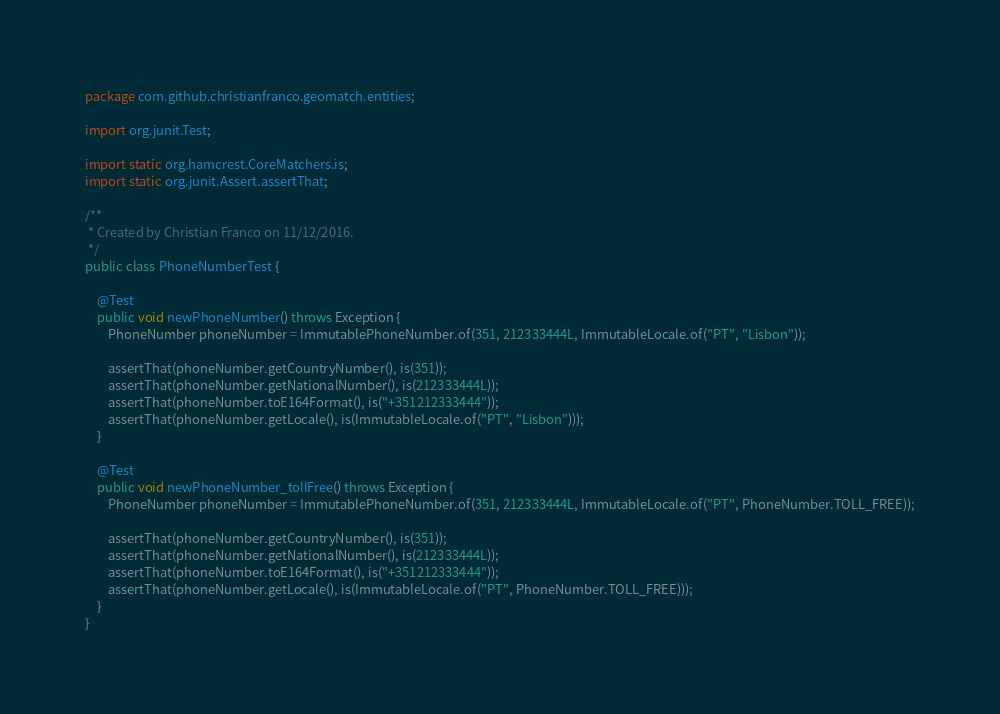<code> <loc_0><loc_0><loc_500><loc_500><_Java_>package com.github.christianfranco.geomatch.entities;

import org.junit.Test;

import static org.hamcrest.CoreMatchers.is;
import static org.junit.Assert.assertThat;

/**
 * Created by Christian Franco on 11/12/2016.
 */
public class PhoneNumberTest {

    @Test
    public void newPhoneNumber() throws Exception {
        PhoneNumber phoneNumber = ImmutablePhoneNumber.of(351, 212333444L, ImmutableLocale.of("PT", "Lisbon"));

        assertThat(phoneNumber.getCountryNumber(), is(351));
        assertThat(phoneNumber.getNationalNumber(), is(212333444L));
        assertThat(phoneNumber.toE164Format(), is("+351212333444"));
        assertThat(phoneNumber.getLocale(), is(ImmutableLocale.of("PT", "Lisbon")));
    }

    @Test
    public void newPhoneNumber_tollFree() throws Exception {
        PhoneNumber phoneNumber = ImmutablePhoneNumber.of(351, 212333444L, ImmutableLocale.of("PT", PhoneNumber.TOLL_FREE));

        assertThat(phoneNumber.getCountryNumber(), is(351));
        assertThat(phoneNumber.getNationalNumber(), is(212333444L));
        assertThat(phoneNumber.toE164Format(), is("+351212333444"));
        assertThat(phoneNumber.getLocale(), is(ImmutableLocale.of("PT", PhoneNumber.TOLL_FREE)));
    }
}</code> 